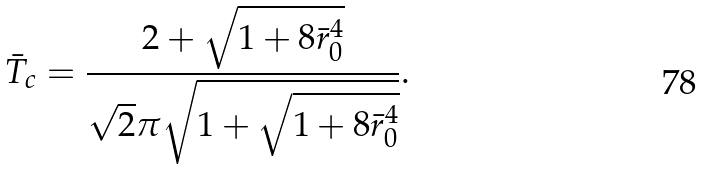<formula> <loc_0><loc_0><loc_500><loc_500>\bar { T } _ { c } = \frac { 2 + \sqrt { 1 + 8 \bar { r } _ { 0 } ^ { 4 } } } { { \sqrt { 2 } } \pi \sqrt { 1 + \sqrt { 1 + 8 \bar { r } _ { 0 } ^ { 4 } } } } .</formula> 